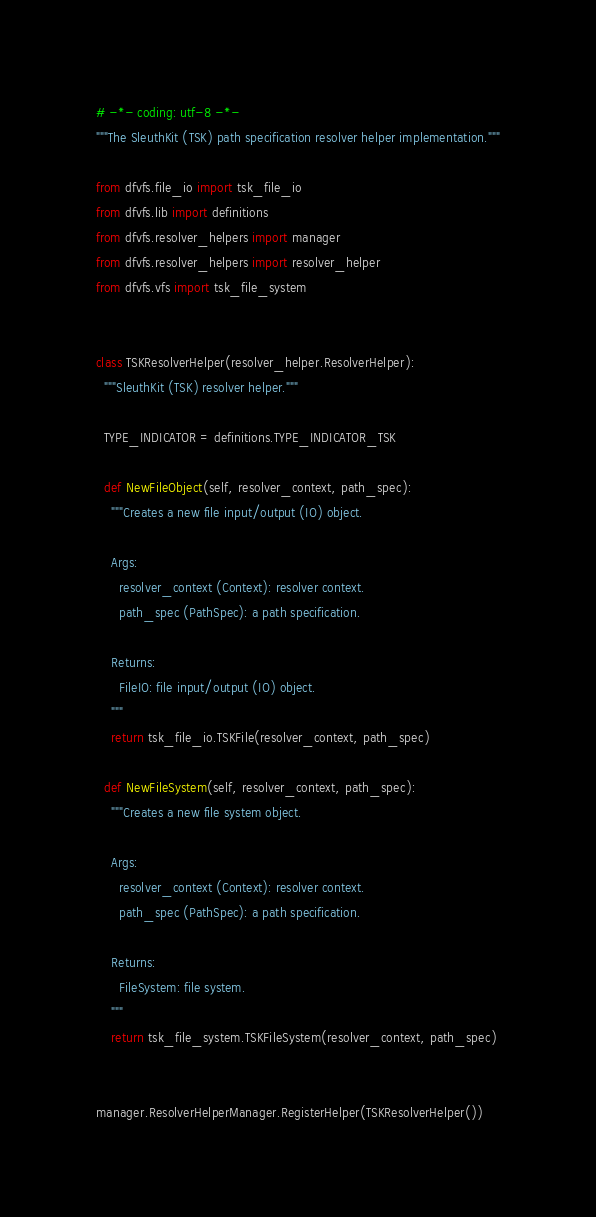<code> <loc_0><loc_0><loc_500><loc_500><_Python_># -*- coding: utf-8 -*-
"""The SleuthKit (TSK) path specification resolver helper implementation."""

from dfvfs.file_io import tsk_file_io
from dfvfs.lib import definitions
from dfvfs.resolver_helpers import manager
from dfvfs.resolver_helpers import resolver_helper
from dfvfs.vfs import tsk_file_system


class TSKResolverHelper(resolver_helper.ResolverHelper):
  """SleuthKit (TSK) resolver helper."""

  TYPE_INDICATOR = definitions.TYPE_INDICATOR_TSK

  def NewFileObject(self, resolver_context, path_spec):
    """Creates a new file input/output (IO) object.

    Args:
      resolver_context (Context): resolver context.
      path_spec (PathSpec): a path specification.

    Returns:
      FileIO: file input/output (IO) object.
    """
    return tsk_file_io.TSKFile(resolver_context, path_spec)

  def NewFileSystem(self, resolver_context, path_spec):
    """Creates a new file system object.

    Args:
      resolver_context (Context): resolver context.
      path_spec (PathSpec): a path specification.

    Returns:
      FileSystem: file system.
    """
    return tsk_file_system.TSKFileSystem(resolver_context, path_spec)


manager.ResolverHelperManager.RegisterHelper(TSKResolverHelper())
</code> 